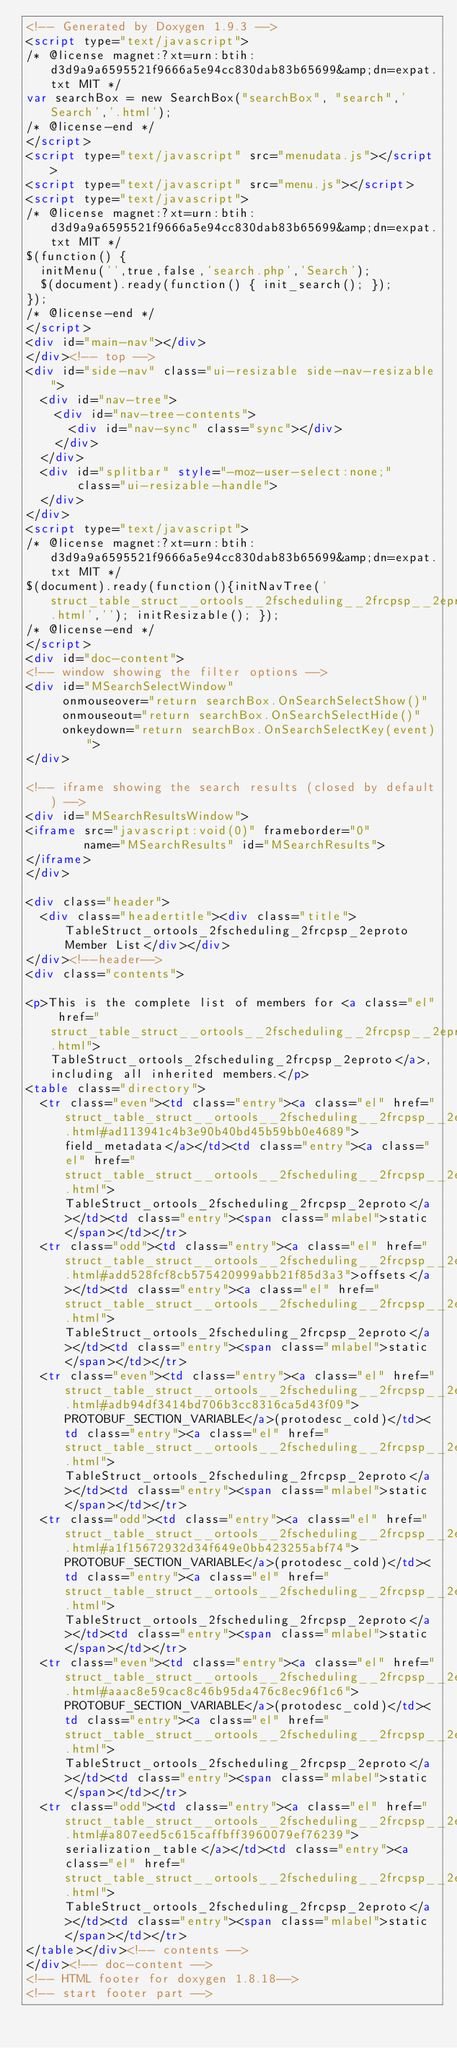Convert code to text. <code><loc_0><loc_0><loc_500><loc_500><_HTML_><!-- Generated by Doxygen 1.9.3 -->
<script type="text/javascript">
/* @license magnet:?xt=urn:btih:d3d9a9a6595521f9666a5e94cc830dab83b65699&amp;dn=expat.txt MIT */
var searchBox = new SearchBox("searchBox", "search",'Search','.html');
/* @license-end */
</script>
<script type="text/javascript" src="menudata.js"></script>
<script type="text/javascript" src="menu.js"></script>
<script type="text/javascript">
/* @license magnet:?xt=urn:btih:d3d9a9a6595521f9666a5e94cc830dab83b65699&amp;dn=expat.txt MIT */
$(function() {
  initMenu('',true,false,'search.php','Search');
  $(document).ready(function() { init_search(); });
});
/* @license-end */
</script>
<div id="main-nav"></div>
</div><!-- top -->
<div id="side-nav" class="ui-resizable side-nav-resizable">
  <div id="nav-tree">
    <div id="nav-tree-contents">
      <div id="nav-sync" class="sync"></div>
    </div>
  </div>
  <div id="splitbar" style="-moz-user-select:none;" 
       class="ui-resizable-handle">
  </div>
</div>
<script type="text/javascript">
/* @license magnet:?xt=urn:btih:d3d9a9a6595521f9666a5e94cc830dab83b65699&amp;dn=expat.txt MIT */
$(document).ready(function(){initNavTree('struct_table_struct__ortools__2fscheduling__2frcpsp__2eproto.html',''); initResizable(); });
/* @license-end */
</script>
<div id="doc-content">
<!-- window showing the filter options -->
<div id="MSearchSelectWindow"
     onmouseover="return searchBox.OnSearchSelectShow()"
     onmouseout="return searchBox.OnSearchSelectHide()"
     onkeydown="return searchBox.OnSearchSelectKey(event)">
</div>

<!-- iframe showing the search results (closed by default) -->
<div id="MSearchResultsWindow">
<iframe src="javascript:void(0)" frameborder="0" 
        name="MSearchResults" id="MSearchResults">
</iframe>
</div>

<div class="header">
  <div class="headertitle"><div class="title">TableStruct_ortools_2fscheduling_2frcpsp_2eproto Member List</div></div>
</div><!--header-->
<div class="contents">

<p>This is the complete list of members for <a class="el" href="struct_table_struct__ortools__2fscheduling__2frcpsp__2eproto.html">TableStruct_ortools_2fscheduling_2frcpsp_2eproto</a>, including all inherited members.</p>
<table class="directory">
  <tr class="even"><td class="entry"><a class="el" href="struct_table_struct__ortools__2fscheduling__2frcpsp__2eproto.html#ad113941c4b3e90b40bd45b59bb0e4689">field_metadata</a></td><td class="entry"><a class="el" href="struct_table_struct__ortools__2fscheduling__2frcpsp__2eproto.html">TableStruct_ortools_2fscheduling_2frcpsp_2eproto</a></td><td class="entry"><span class="mlabel">static</span></td></tr>
  <tr class="odd"><td class="entry"><a class="el" href="struct_table_struct__ortools__2fscheduling__2frcpsp__2eproto.html#add528fcf8cb575420999abb21f85d3a3">offsets</a></td><td class="entry"><a class="el" href="struct_table_struct__ortools__2fscheduling__2frcpsp__2eproto.html">TableStruct_ortools_2fscheduling_2frcpsp_2eproto</a></td><td class="entry"><span class="mlabel">static</span></td></tr>
  <tr class="even"><td class="entry"><a class="el" href="struct_table_struct__ortools__2fscheduling__2frcpsp__2eproto.html#adb94df3414bd706b3cc8316ca5d43f09">PROTOBUF_SECTION_VARIABLE</a>(protodesc_cold)</td><td class="entry"><a class="el" href="struct_table_struct__ortools__2fscheduling__2frcpsp__2eproto.html">TableStruct_ortools_2fscheduling_2frcpsp_2eproto</a></td><td class="entry"><span class="mlabel">static</span></td></tr>
  <tr class="odd"><td class="entry"><a class="el" href="struct_table_struct__ortools__2fscheduling__2frcpsp__2eproto.html#a1f15672932d34f649e0bb423255abf74">PROTOBUF_SECTION_VARIABLE</a>(protodesc_cold)</td><td class="entry"><a class="el" href="struct_table_struct__ortools__2fscheduling__2frcpsp__2eproto.html">TableStruct_ortools_2fscheduling_2frcpsp_2eproto</a></td><td class="entry"><span class="mlabel">static</span></td></tr>
  <tr class="even"><td class="entry"><a class="el" href="struct_table_struct__ortools__2fscheduling__2frcpsp__2eproto.html#aaac8e59cac8c46b95da476c8ec96f1c6">PROTOBUF_SECTION_VARIABLE</a>(protodesc_cold)</td><td class="entry"><a class="el" href="struct_table_struct__ortools__2fscheduling__2frcpsp__2eproto.html">TableStruct_ortools_2fscheduling_2frcpsp_2eproto</a></td><td class="entry"><span class="mlabel">static</span></td></tr>
  <tr class="odd"><td class="entry"><a class="el" href="struct_table_struct__ortools__2fscheduling__2frcpsp__2eproto.html#a807eed5c615caffbff3960079ef76239">serialization_table</a></td><td class="entry"><a class="el" href="struct_table_struct__ortools__2fscheduling__2frcpsp__2eproto.html">TableStruct_ortools_2fscheduling_2frcpsp_2eproto</a></td><td class="entry"><span class="mlabel">static</span></td></tr>
</table></div><!-- contents -->
</div><!-- doc-content -->
<!-- HTML footer for doxygen 1.8.18-->
<!-- start footer part --></code> 